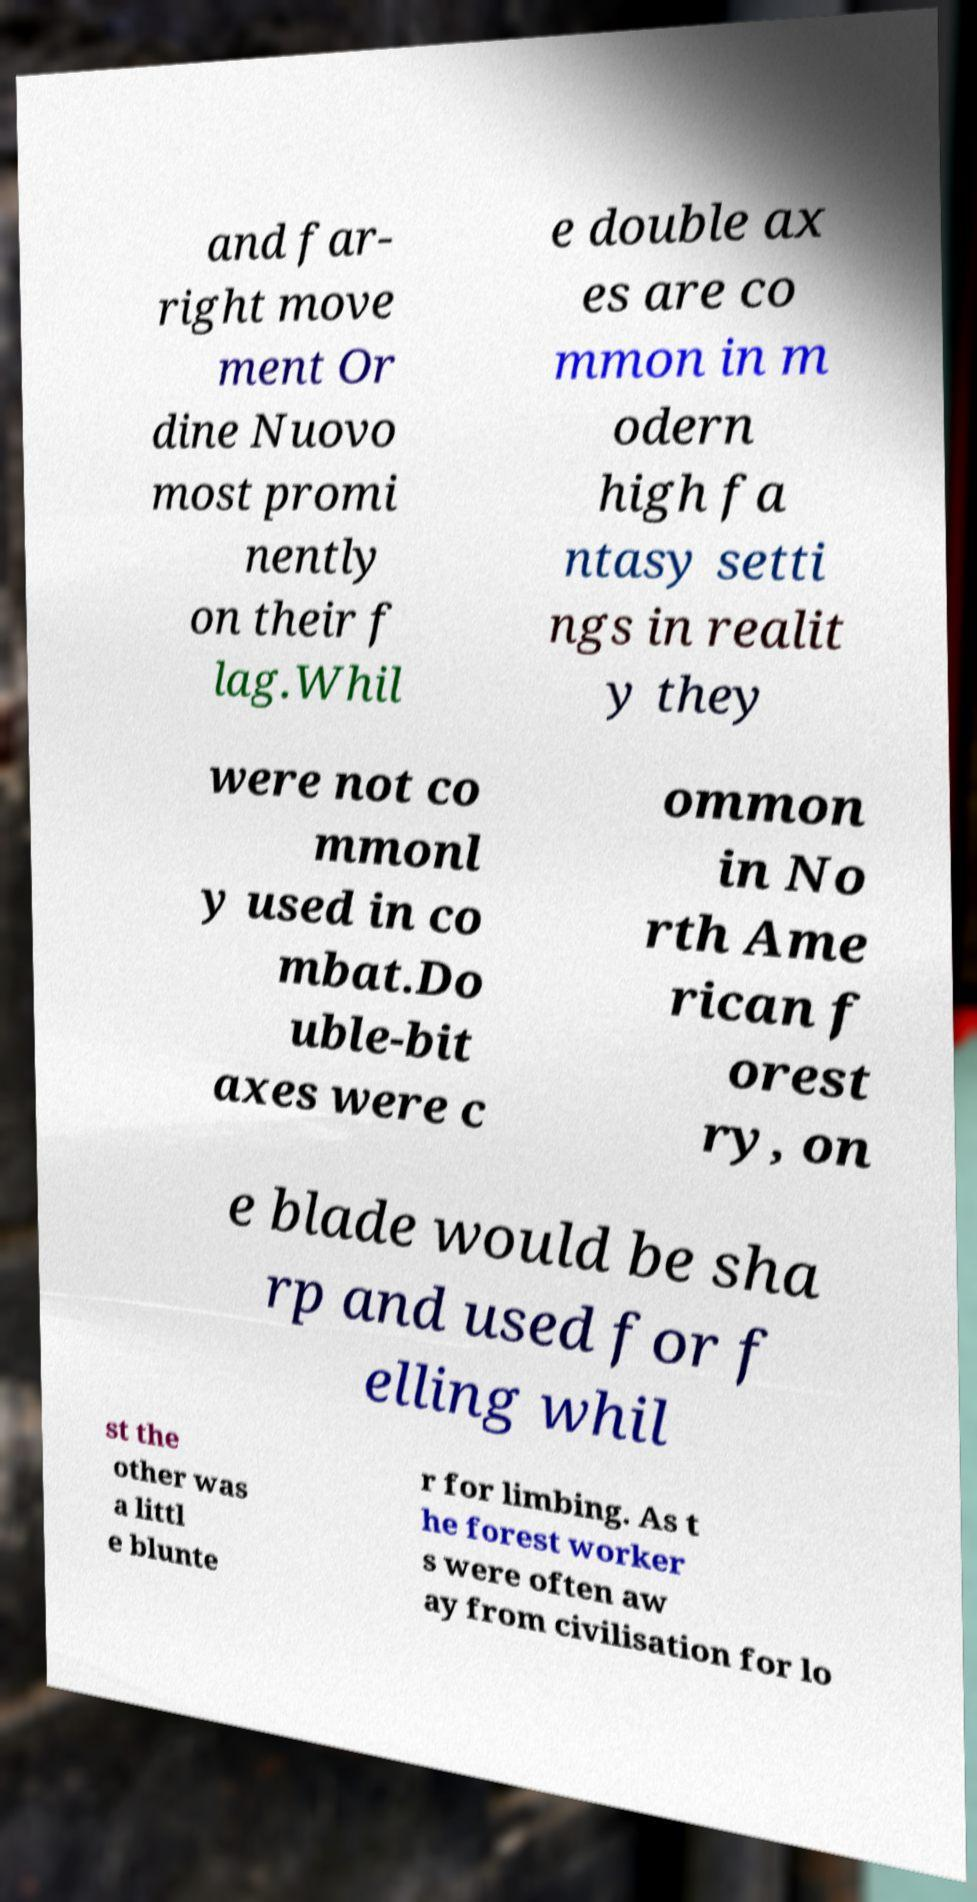For documentation purposes, I need the text within this image transcribed. Could you provide that? and far- right move ment Or dine Nuovo most promi nently on their f lag.Whil e double ax es are co mmon in m odern high fa ntasy setti ngs in realit y they were not co mmonl y used in co mbat.Do uble-bit axes were c ommon in No rth Ame rican f orest ry, on e blade would be sha rp and used for f elling whil st the other was a littl e blunte r for limbing. As t he forest worker s were often aw ay from civilisation for lo 